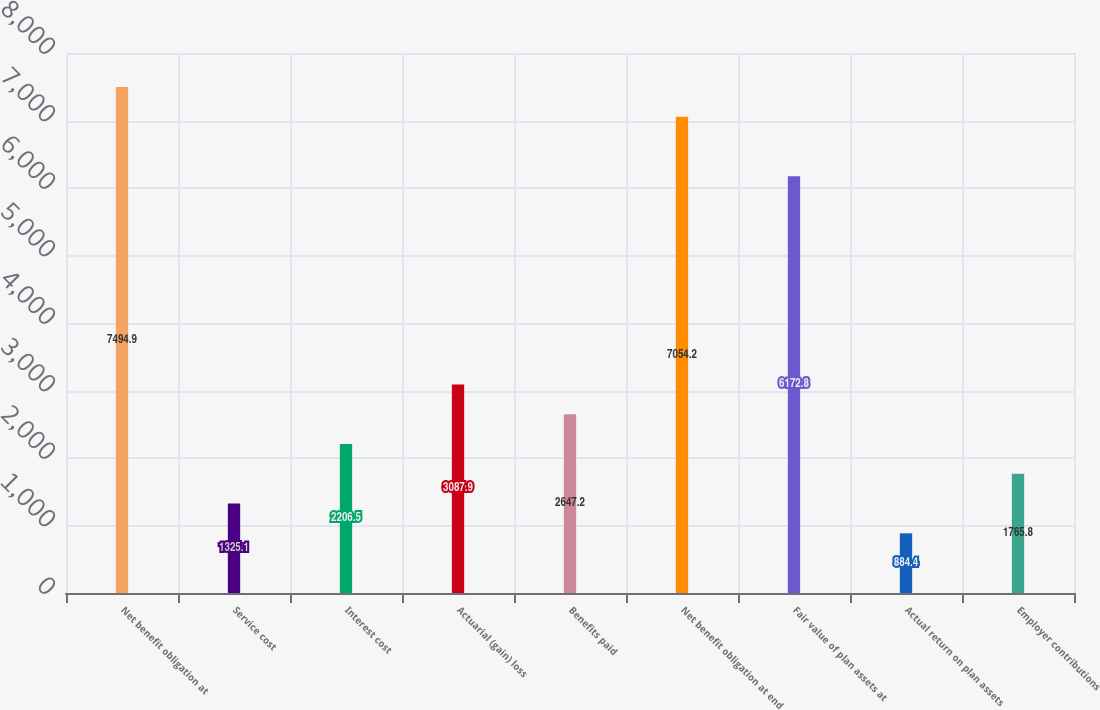<chart> <loc_0><loc_0><loc_500><loc_500><bar_chart><fcel>Net benefit obligation at<fcel>Service cost<fcel>Interest cost<fcel>Actuarial (gain) loss<fcel>Benefits paid<fcel>Net benefit obligation at end<fcel>Fair value of plan assets at<fcel>Actual return on plan assets<fcel>Employer contributions<nl><fcel>7494.9<fcel>1325.1<fcel>2206.5<fcel>3087.9<fcel>2647.2<fcel>7054.2<fcel>6172.8<fcel>884.4<fcel>1765.8<nl></chart> 